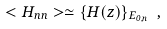<formula> <loc_0><loc_0><loc_500><loc_500>< H _ { n n } > \simeq \{ H ( { z } ) \} _ { E _ { 0 , n } } \ ,</formula> 